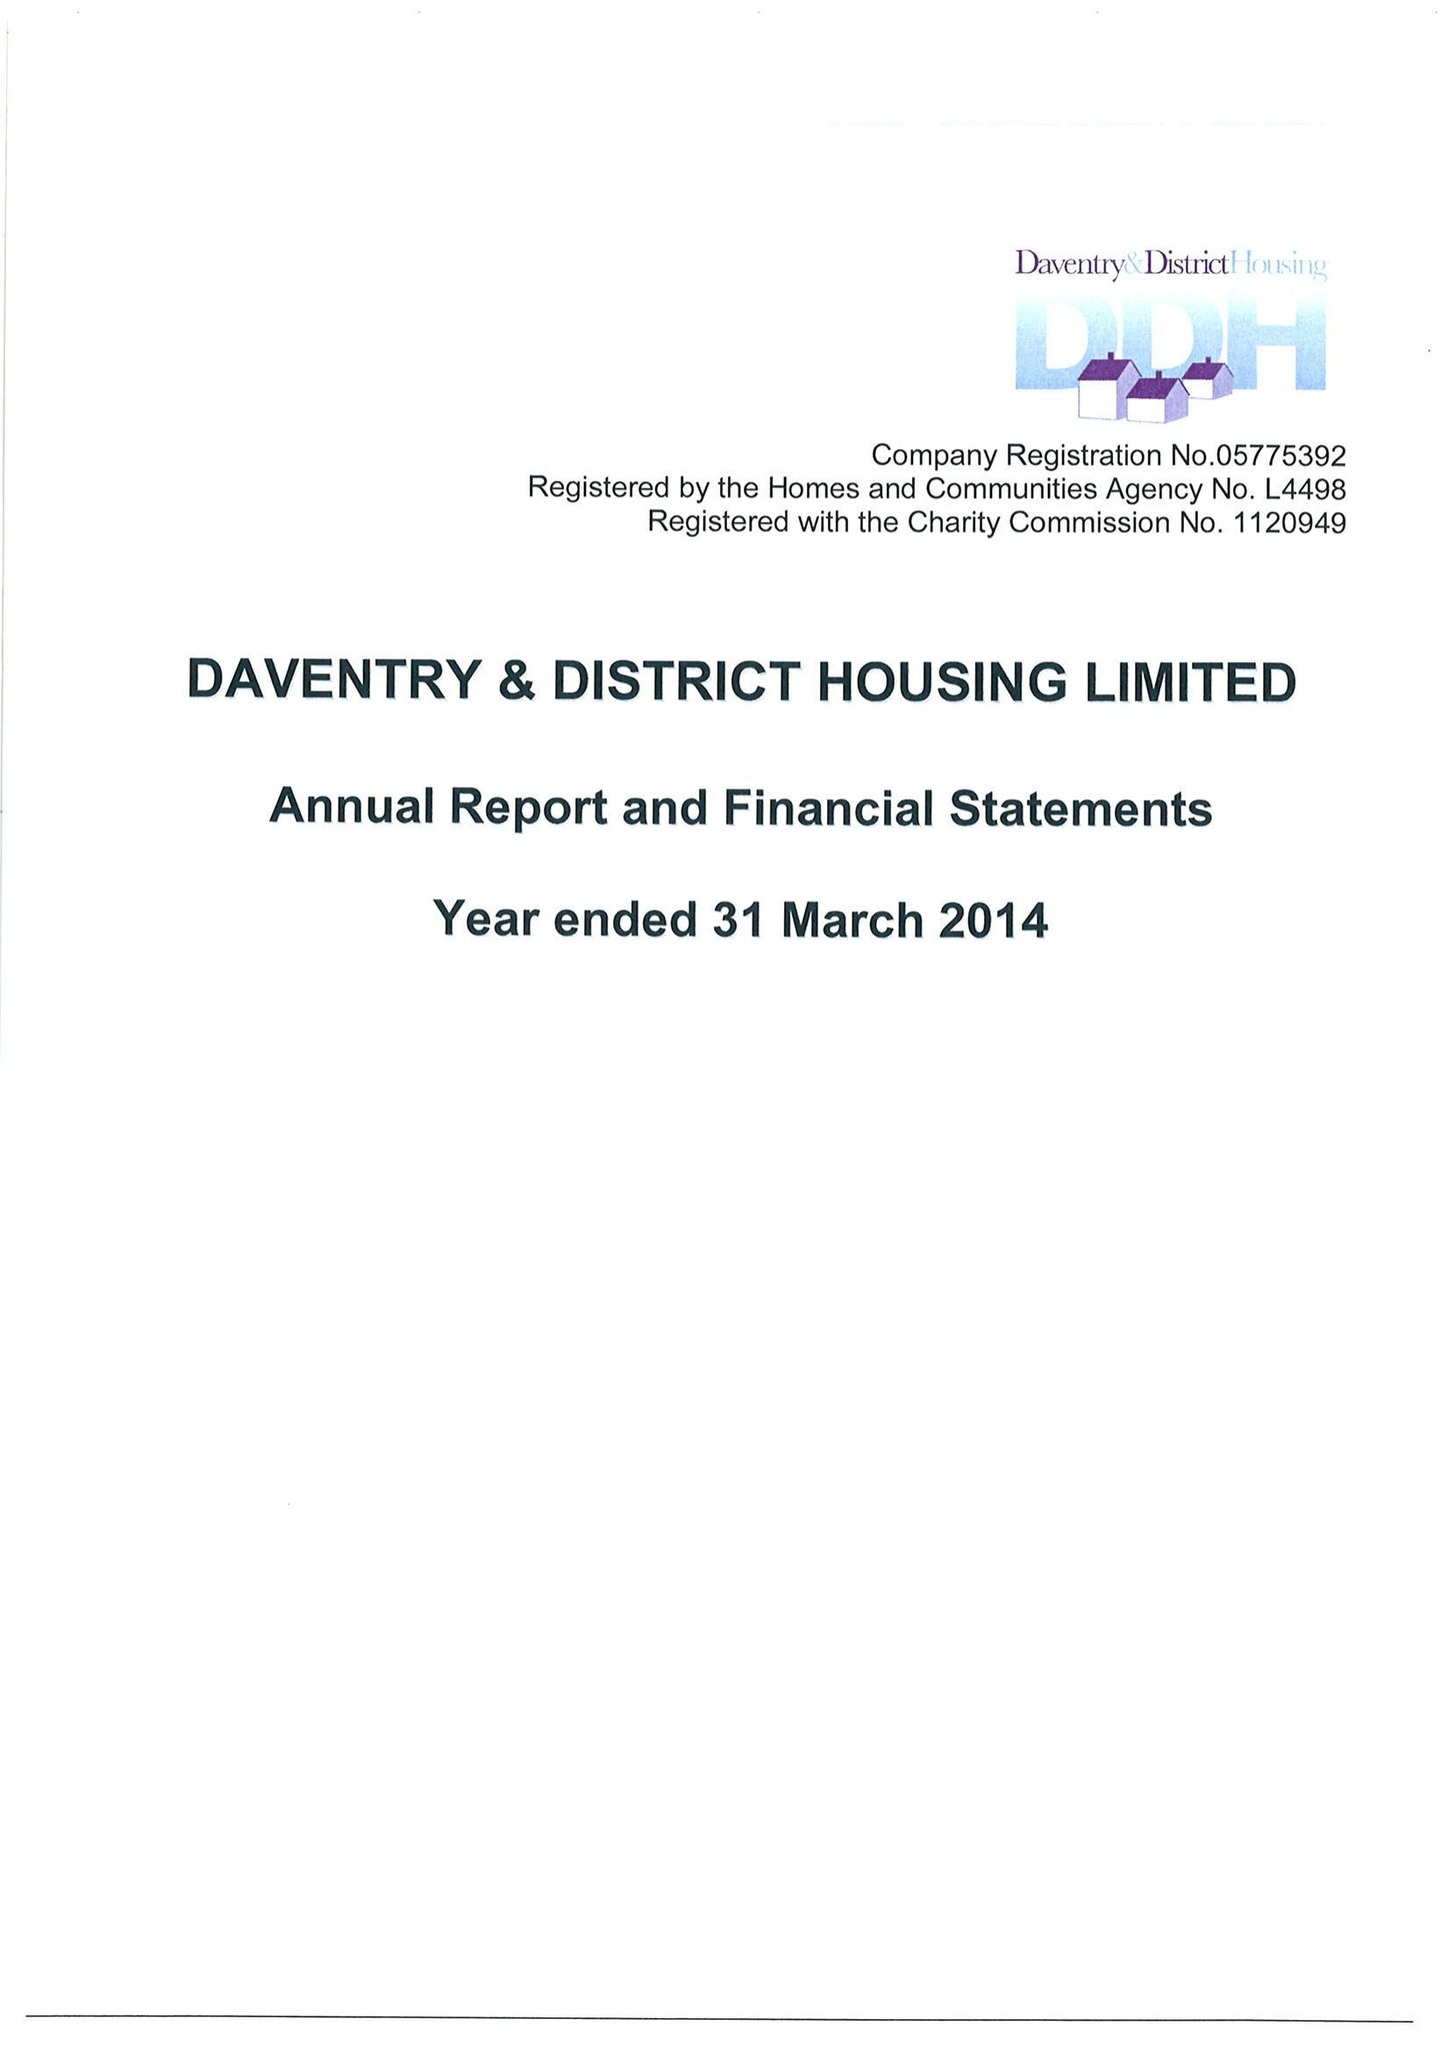What is the value for the report_date?
Answer the question using a single word or phrase. 2014-03-31 